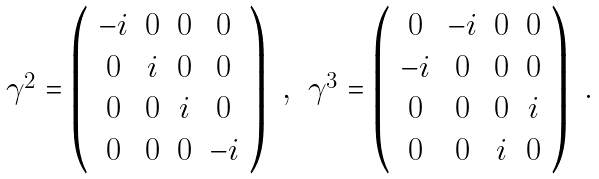<formula> <loc_0><loc_0><loc_500><loc_500>\begin{array} { c c } \gamma ^ { 2 } = \left ( \begin{array} { c c c c } - i & 0 & 0 & 0 \\ 0 & i & 0 & 0 \\ 0 & 0 & i & 0 \\ 0 & 0 & 0 & - i \\ \end{array} \right ) \ , & \gamma ^ { 3 } = \left ( \begin{array} { c c c c } 0 & - i & 0 & 0 \\ - i & 0 & 0 & 0 \\ 0 & 0 & 0 & i \\ 0 & 0 & i & 0 \\ \end{array} \right ) \ . \end{array}</formula> 